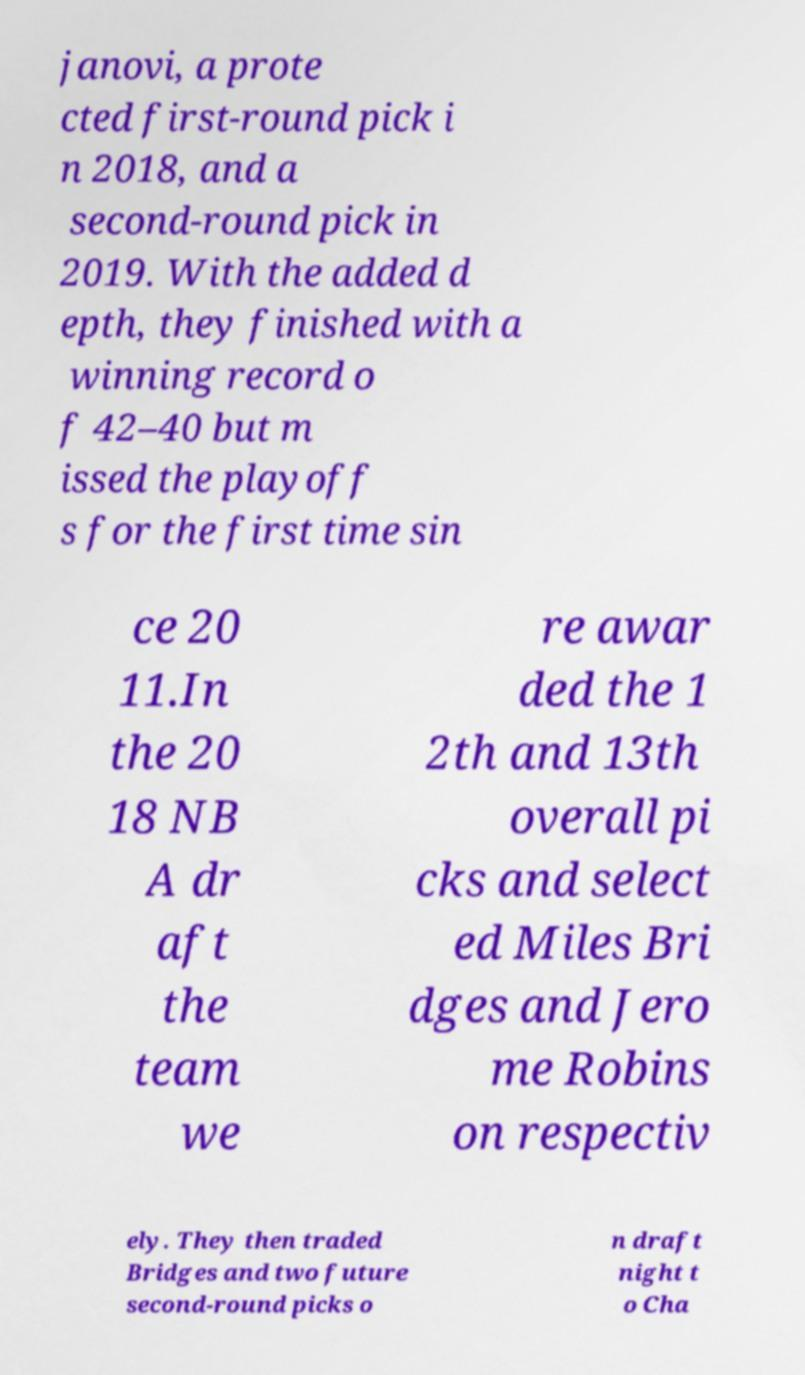Please read and relay the text visible in this image. What does it say? janovi, a prote cted first-round pick i n 2018, and a second-round pick in 2019. With the added d epth, they finished with a winning record o f 42–40 but m issed the playoff s for the first time sin ce 20 11.In the 20 18 NB A dr aft the team we re awar ded the 1 2th and 13th overall pi cks and select ed Miles Bri dges and Jero me Robins on respectiv ely. They then traded Bridges and two future second-round picks o n draft night t o Cha 